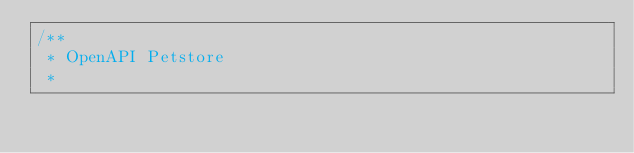Convert code to text. <code><loc_0><loc_0><loc_500><loc_500><_Kotlin_>/**
 * OpenAPI Petstore
 *</code> 